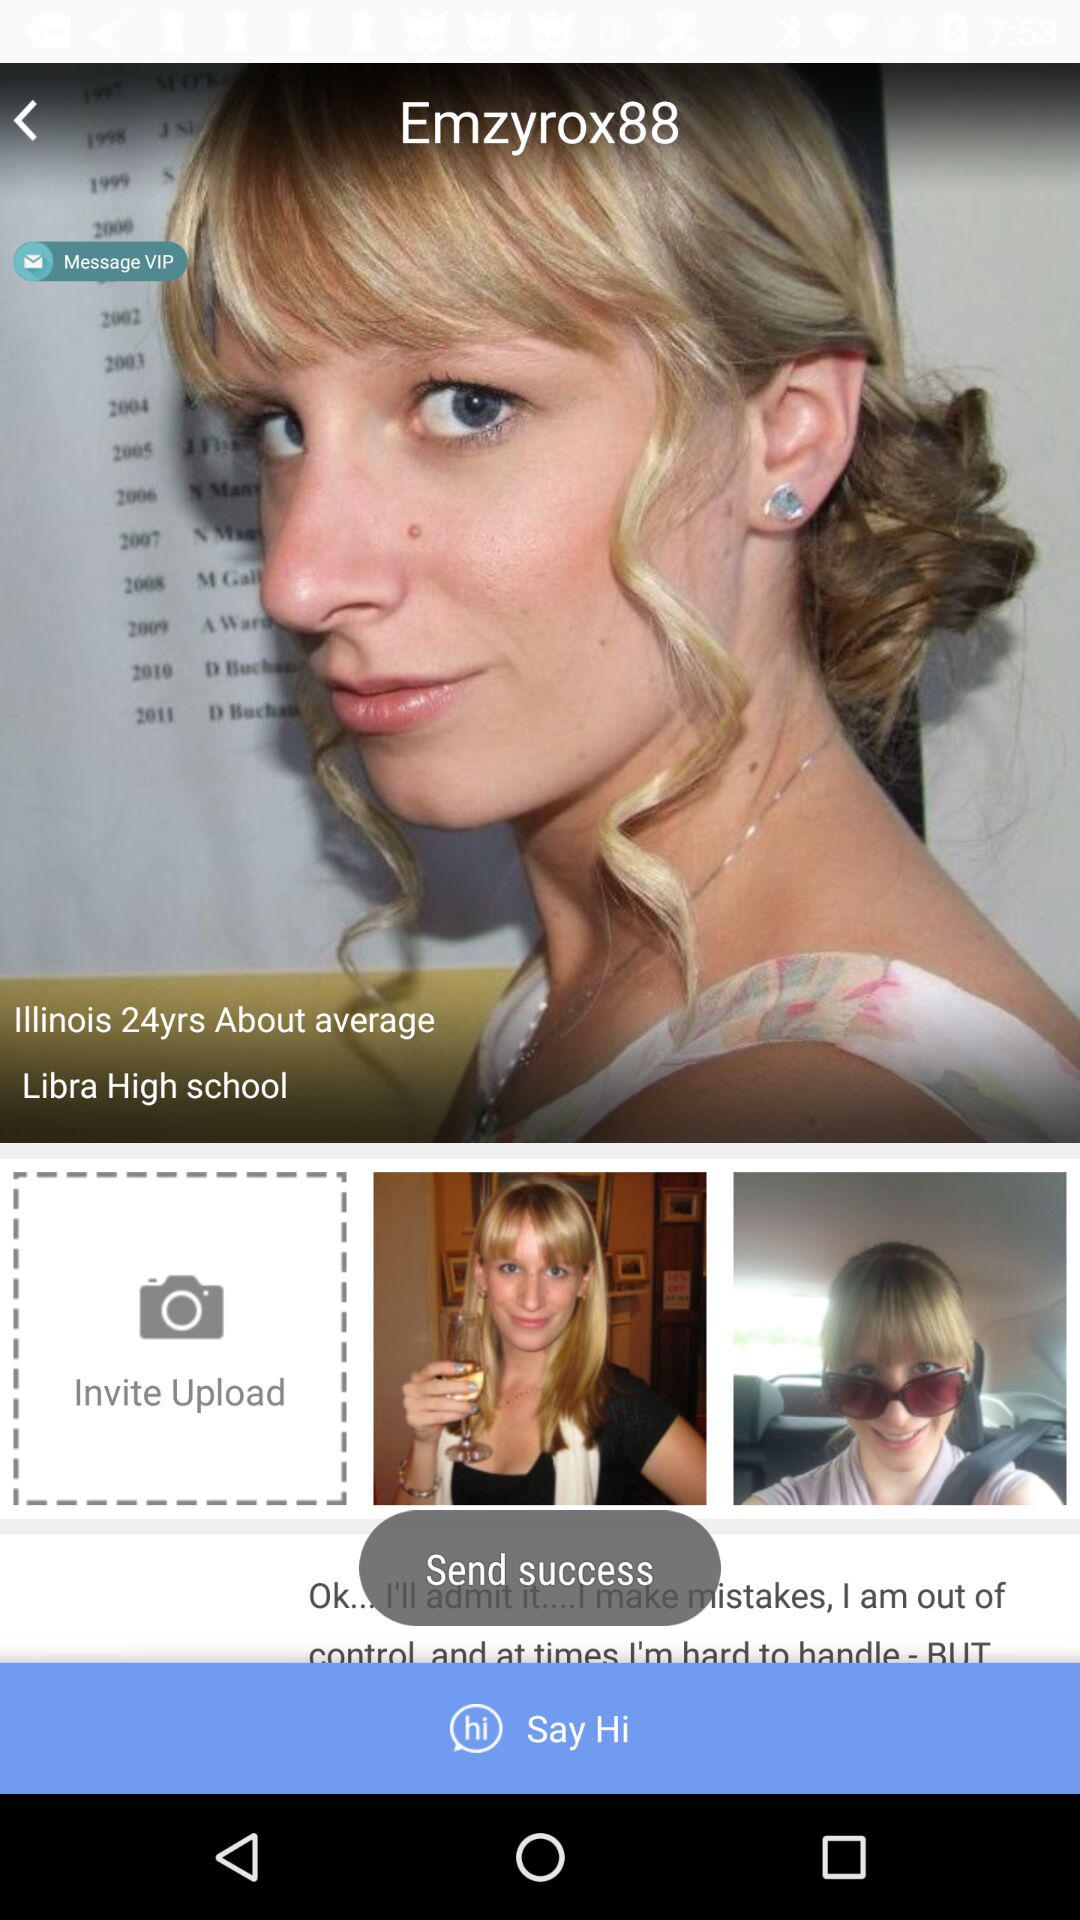What is the user name? The user name is Emzyrox88. 